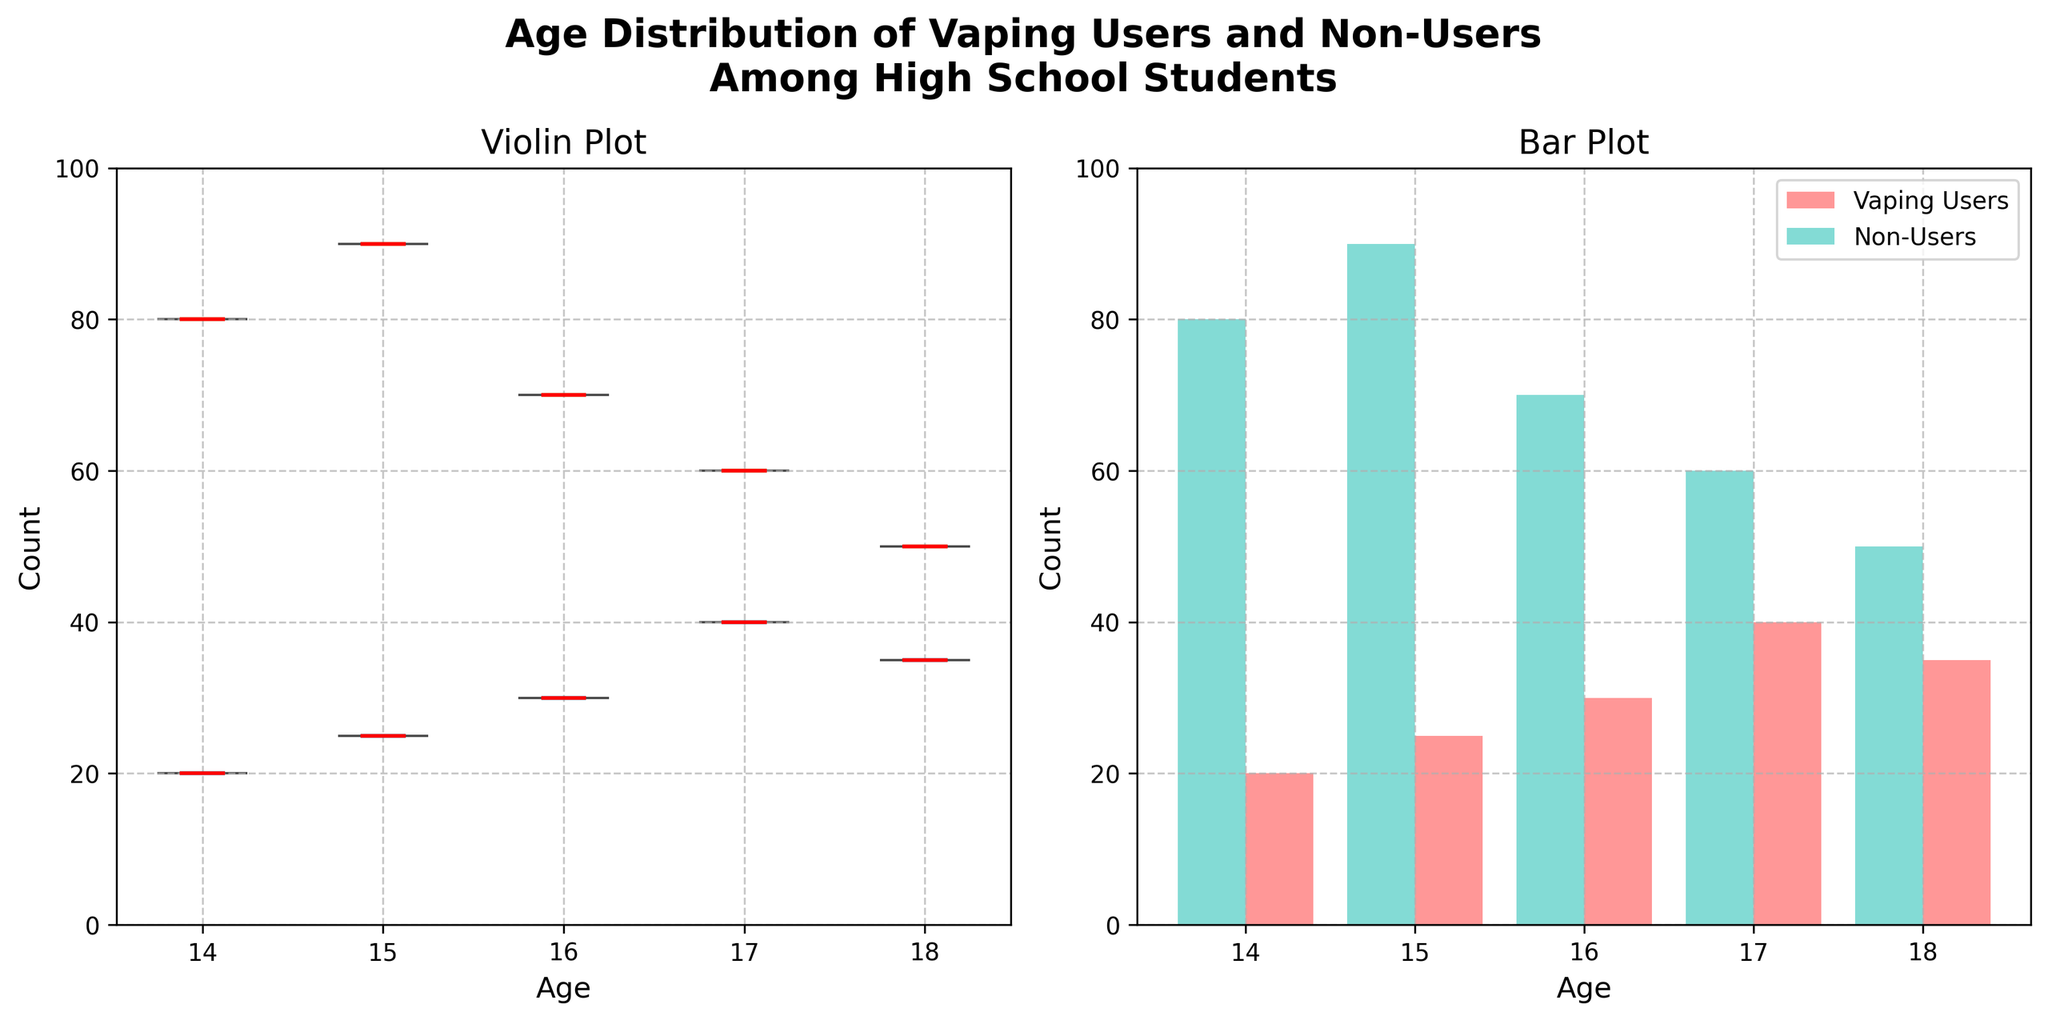What's the title of the figure? The title of a figure is typically positioned at the top and gives an overall idea about the content of the visualization. In this case, it mentions both the age distribution and group categorization.
Answer: Age Distribution of Vaping Users and Non-Users Among High School Students How many groups are compared in the figure? The figure divides the data into two distinct categories or groups, which can be distinguished by their titles or the legend.
Answer: 2 What colors are used to represent Vaping Users and Non-Users? Observing the different colors used in the figure and checking the legend to identify them: Vaping Users are represented by a pinkish color and Non-Users by a turquoise color.
Answer: Pink and Turquoise What is the age range considered in the figure? Observing the x-axis, which shows the ages, helps determine the range under consideration. In this case, it spans from 14 to 18.
Answer: 14-18 Which group has the higher count at age 17? Comparing the height of the bars at age 17 for both groups on the bar plot - the Non-Users have a bar reaching 60, whereas the Vaping Users bar reaches 40.
Answer: Non-Users What's the mean value of counts for Vaping Users across all ages? The violin plot has a line showing the mean values. Summing up the mean values at each age (20+25+30+40+35) and dividing by the number of ages (5) gives the mean count.
Answer: 30 What's the difference between the highest count of Vaping Users and Non-Users? The highest count for Vaping Users is at age 17 (40), and for Non-Users it is at age 15 (90). Subtracting these values gives the difference (90 - 40).
Answer: 50 Which group shows a higher variability in counts across ages? Observing the spread of the violins, especially the wider portions, helps determine which group is more variable. Non-Users show higher variability with counts ranging from 50-90.
Answer: Non-Users What is the median value for Vaping Users at age 18? The median is indicated by the red line in the violin plot. For Vaping Users at age 18, the red line is positioned at 35.
Answer: 35 